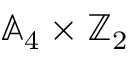Convert formula to latex. <formula><loc_0><loc_0><loc_500><loc_500>\mathbb { A } _ { 4 } \times \mathbb { Z } _ { 2 }</formula> 